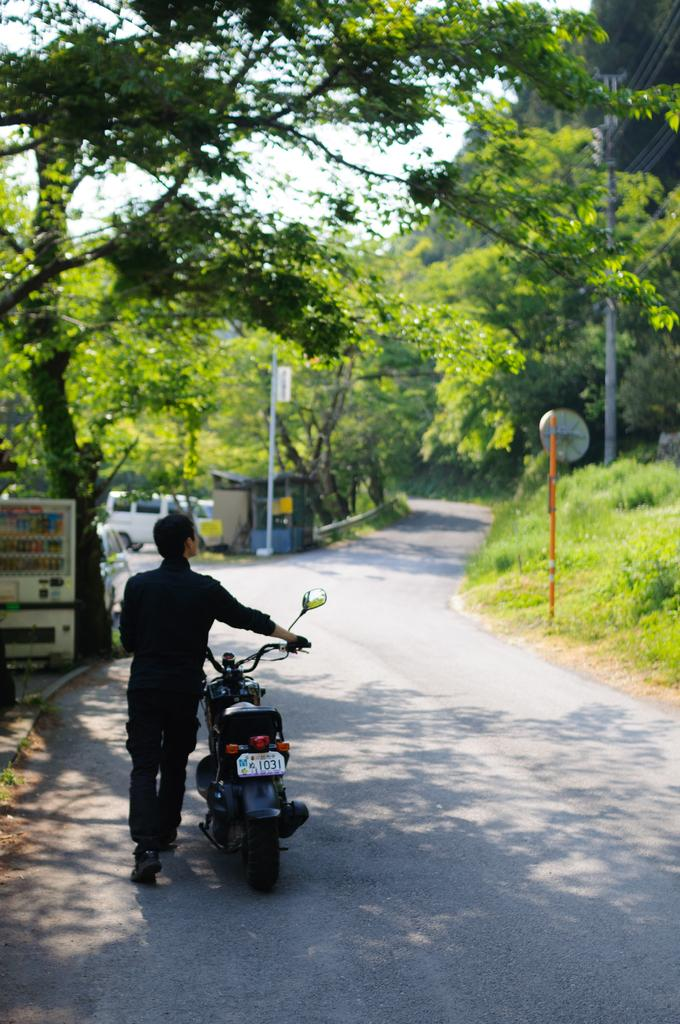What is the person in the image doing? The person is walking in the image. What is the person holding while walking? The person is holding a bike. What type of terrain is visible in the image? There is grass visible in the image. What is the color of the object in the image? There is a white object in the image. What type of vegetation is present in the image? There are trees in the image. What type of transportation is present in the image? There is a vehicle in the image. What type of structure is present in the image? There is a building in the image. What is visible in the background of the image? The sky is visible in the background of the image. How many beds are visible in the image? There are no beds present in the image. What type of tray is being used by the person in the image? There is no tray present in the image. What type of tank is visible in the image? There is no tank present in the image. 